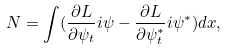<formula> <loc_0><loc_0><loc_500><loc_500>N = \int ( \frac { \partial L } { \partial \psi _ { t } } i \psi - \frac { \partial L } { \partial \psi _ { t } ^ { * } } i \psi ^ { * } ) d x ,</formula> 